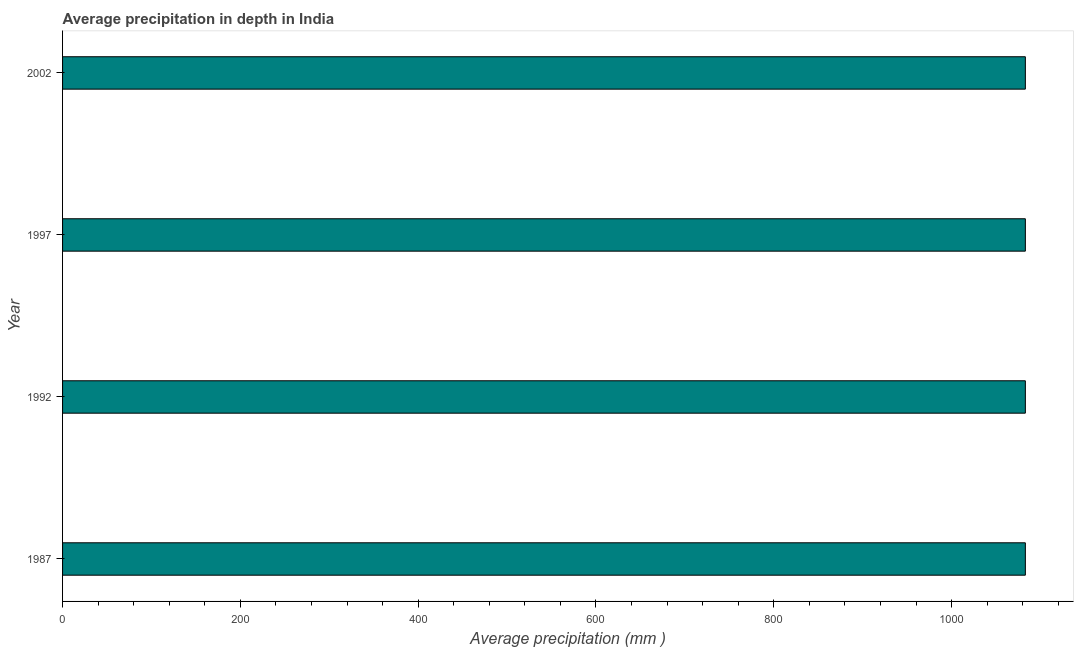Does the graph contain grids?
Make the answer very short. No. What is the title of the graph?
Ensure brevity in your answer.  Average precipitation in depth in India. What is the label or title of the X-axis?
Provide a succinct answer. Average precipitation (mm ). What is the average precipitation in depth in 2002?
Ensure brevity in your answer.  1083. Across all years, what is the maximum average precipitation in depth?
Your answer should be very brief. 1083. Across all years, what is the minimum average precipitation in depth?
Give a very brief answer. 1083. In which year was the average precipitation in depth minimum?
Provide a succinct answer. 1987. What is the sum of the average precipitation in depth?
Your answer should be very brief. 4332. What is the average average precipitation in depth per year?
Your answer should be compact. 1083. What is the median average precipitation in depth?
Keep it short and to the point. 1083. In how many years, is the average precipitation in depth greater than 600 mm?
Your answer should be compact. 4. What is the ratio of the average precipitation in depth in 1987 to that in 1992?
Provide a short and direct response. 1. Is the average precipitation in depth in 1987 less than that in 1997?
Offer a very short reply. No. In how many years, is the average precipitation in depth greater than the average average precipitation in depth taken over all years?
Provide a short and direct response. 0. How many bars are there?
Give a very brief answer. 4. Are all the bars in the graph horizontal?
Your answer should be compact. Yes. How many years are there in the graph?
Offer a very short reply. 4. What is the difference between two consecutive major ticks on the X-axis?
Your answer should be very brief. 200. What is the Average precipitation (mm ) in 1987?
Provide a succinct answer. 1083. What is the Average precipitation (mm ) in 1992?
Your response must be concise. 1083. What is the Average precipitation (mm ) of 1997?
Provide a short and direct response. 1083. What is the Average precipitation (mm ) of 2002?
Provide a short and direct response. 1083. What is the difference between the Average precipitation (mm ) in 1987 and 2002?
Your response must be concise. 0. What is the difference between the Average precipitation (mm ) in 1992 and 1997?
Ensure brevity in your answer.  0. What is the difference between the Average precipitation (mm ) in 1992 and 2002?
Keep it short and to the point. 0. What is the difference between the Average precipitation (mm ) in 1997 and 2002?
Keep it short and to the point. 0. What is the ratio of the Average precipitation (mm ) in 1987 to that in 1992?
Offer a very short reply. 1. What is the ratio of the Average precipitation (mm ) in 1992 to that in 1997?
Provide a short and direct response. 1. What is the ratio of the Average precipitation (mm ) in 1992 to that in 2002?
Your answer should be very brief. 1. What is the ratio of the Average precipitation (mm ) in 1997 to that in 2002?
Offer a very short reply. 1. 